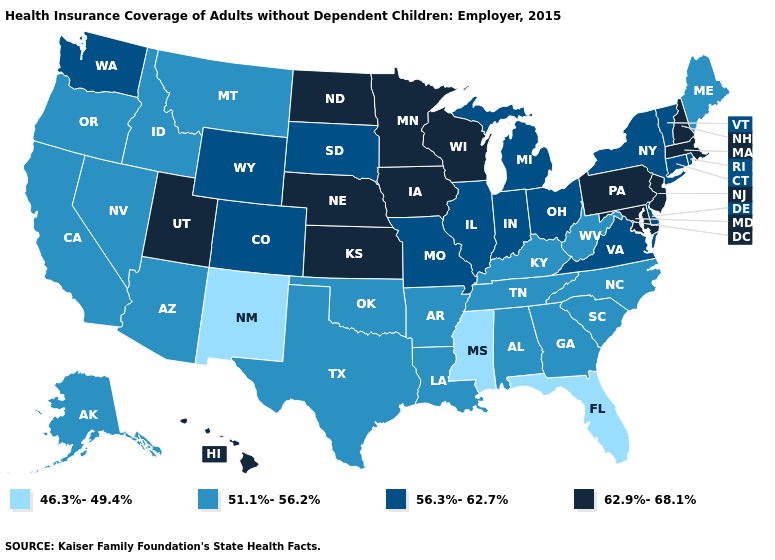What is the lowest value in states that border Wisconsin?
Short answer required. 56.3%-62.7%. Among the states that border Nevada , does California have the lowest value?
Quick response, please. Yes. Name the states that have a value in the range 51.1%-56.2%?
Quick response, please. Alabama, Alaska, Arizona, Arkansas, California, Georgia, Idaho, Kentucky, Louisiana, Maine, Montana, Nevada, North Carolina, Oklahoma, Oregon, South Carolina, Tennessee, Texas, West Virginia. What is the value of Idaho?
Quick response, please. 51.1%-56.2%. What is the value of Mississippi?
Answer briefly. 46.3%-49.4%. Among the states that border Wyoming , does Utah have the lowest value?
Write a very short answer. No. Among the states that border Colorado , which have the highest value?
Write a very short answer. Kansas, Nebraska, Utah. What is the value of Georgia?
Keep it brief. 51.1%-56.2%. Does New Mexico have the lowest value in the USA?
Concise answer only. Yes. What is the highest value in states that border Oklahoma?
Short answer required. 62.9%-68.1%. What is the value of New York?
Write a very short answer. 56.3%-62.7%. What is the lowest value in the USA?
Concise answer only. 46.3%-49.4%. What is the value of Massachusetts?
Short answer required. 62.9%-68.1%. Which states have the lowest value in the USA?
Keep it brief. Florida, Mississippi, New Mexico. Which states have the lowest value in the USA?
Write a very short answer. Florida, Mississippi, New Mexico. 